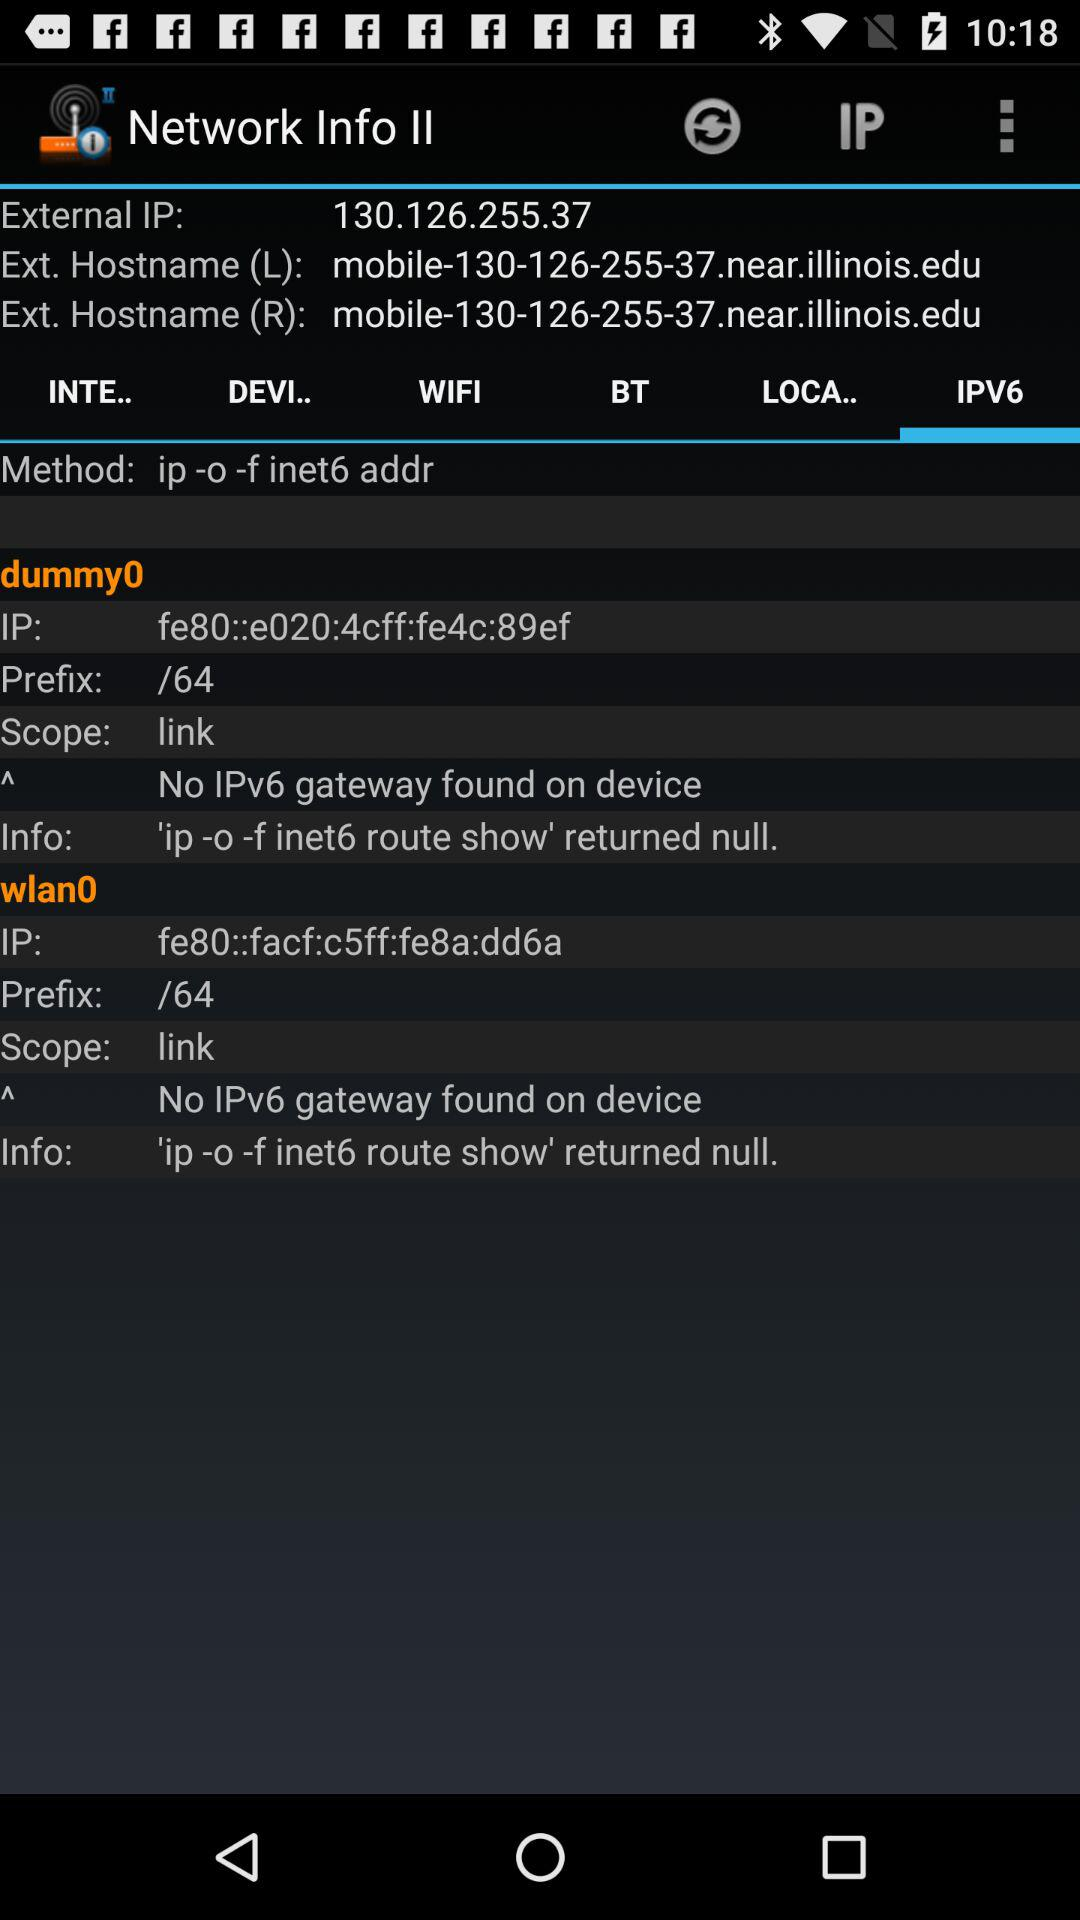What is the external IP address? The external IP address is 130.126.255.37. 